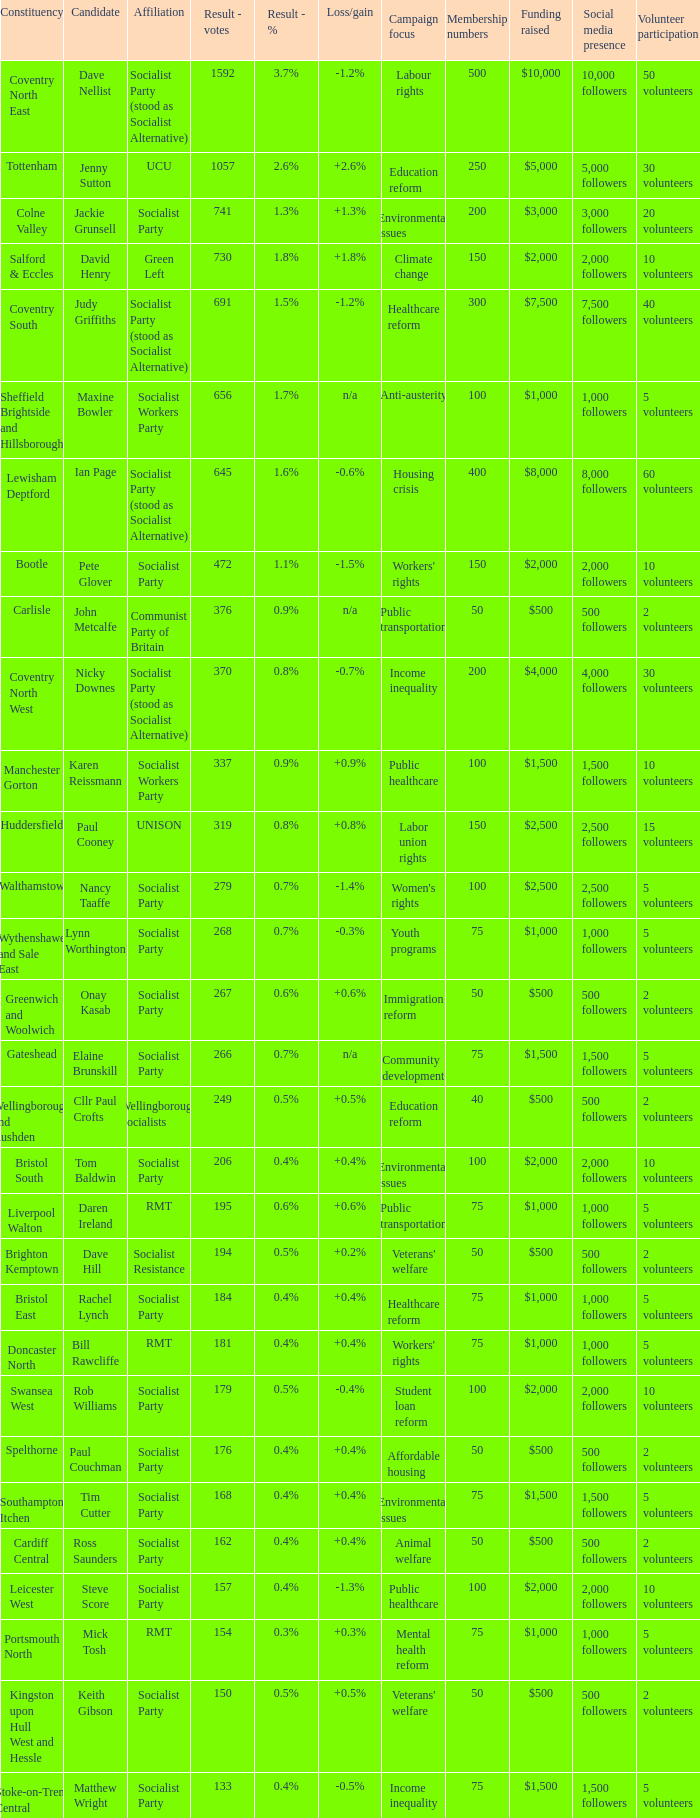Would you be able to parse every entry in this table? {'header': ['Constituency', 'Candidate', 'Affiliation', 'Result - votes', 'Result - %', 'Loss/gain', 'Campaign focus', 'Membership numbers', 'Funding raised', 'Social media presence', 'Volunteer participation'], 'rows': [['Coventry North East', 'Dave Nellist', 'Socialist Party (stood as Socialist Alternative)', '1592', '3.7%', '-1.2%', 'Labour rights', '500', '$10,000', '10,000 followers', '50 volunteers'], ['Tottenham', 'Jenny Sutton', 'UCU', '1057', '2.6%', '+2.6%', 'Education reform', '250', '$5,000', '5,000 followers', '30 volunteers'], ['Colne Valley', 'Jackie Grunsell', 'Socialist Party', '741', '1.3%', '+1.3%', 'Environmental issues', '200', '$3,000', '3,000 followers', '20 volunteers'], ['Salford & Eccles', 'David Henry', 'Green Left', '730', '1.8%', '+1.8%', 'Climate change', '150', '$2,000', '2,000 followers', '10 volunteers'], ['Coventry South', 'Judy Griffiths', 'Socialist Party (stood as Socialist Alternative)', '691', '1.5%', '-1.2%', 'Healthcare reform', '300', '$7,500', '7,500 followers', '40 volunteers'], ['Sheffield Brightside and Hillsborough', 'Maxine Bowler', 'Socialist Workers Party', '656', '1.7%', 'n/a', 'Anti-austerity', '100', '$1,000', '1,000 followers', '5 volunteers'], ['Lewisham Deptford', 'Ian Page', 'Socialist Party (stood as Socialist Alternative)', '645', '1.6%', '-0.6%', 'Housing crisis', '400', '$8,000', '8,000 followers', '60 volunteers'], ['Bootle', 'Pete Glover', 'Socialist Party', '472', '1.1%', '-1.5%', "Workers' rights", '150', '$2,000', '2,000 followers', '10 volunteers'], ['Carlisle', 'John Metcalfe', 'Communist Party of Britain', '376', '0.9%', 'n/a', 'Public transportation', '50', '$500', '500 followers', '2 volunteers'], ['Coventry North West', 'Nicky Downes', 'Socialist Party (stood as Socialist Alternative)', '370', '0.8%', '-0.7%', 'Income inequality', '200', '$4,000', '4,000 followers', '30 volunteers'], ['Manchester Gorton', 'Karen Reissmann', 'Socialist Workers Party', '337', '0.9%', '+0.9%', 'Public healthcare', '100', '$1,500', '1,500 followers', '10 volunteers'], ['Huddersfield', 'Paul Cooney', 'UNISON', '319', '0.8%', '+0.8%', 'Labor union rights', '150', '$2,500', '2,500 followers', '15 volunteers'], ['Walthamstow', 'Nancy Taaffe', 'Socialist Party', '279', '0.7%', '-1.4%', "Women's rights", '100', '$2,500', '2,500 followers', '5 volunteers'], ['Wythenshawe and Sale East', 'Lynn Worthington', 'Socialist Party', '268', '0.7%', '-0.3%', 'Youth programs', '75', '$1,000', '1,000 followers', '5 volunteers'], ['Greenwich and Woolwich', 'Onay Kasab', 'Socialist Party', '267', '0.6%', '+0.6%', 'Immigration reform', '50', '$500', '500 followers', '2 volunteers'], ['Gateshead', 'Elaine Brunskill', 'Socialist Party', '266', '0.7%', 'n/a', 'Community development', '75', '$1,500', '1,500 followers', '5 volunteers'], ['Wellingborough and Rushden', 'Cllr Paul Crofts', 'Wellingborough Socialists', '249', '0.5%', '+0.5%', 'Education reform', '40', '$500', '500 followers', '2 volunteers'], ['Bristol South', 'Tom Baldwin', 'Socialist Party', '206', '0.4%', '+0.4%', 'Environmental issues', '100', '$2,000', '2,000 followers', '10 volunteers'], ['Liverpool Walton', 'Daren Ireland', 'RMT', '195', '0.6%', '+0.6%', 'Public transportation', '75', '$1,000', '1,000 followers', '5 volunteers'], ['Brighton Kemptown', 'Dave Hill', 'Socialist Resistance', '194', '0.5%', '+0.2%', "Veterans' welfare", '50', '$500', '500 followers', '2 volunteers'], ['Bristol East', 'Rachel Lynch', 'Socialist Party', '184', '0.4%', '+0.4%', 'Healthcare reform', '75', '$1,000', '1,000 followers', '5 volunteers'], ['Doncaster North', 'Bill Rawcliffe', 'RMT', '181', '0.4%', '+0.4%', "Workers' rights", '75', '$1,000', '1,000 followers', '5 volunteers'], ['Swansea West', 'Rob Williams', 'Socialist Party', '179', '0.5%', '-0.4%', 'Student loan reform', '100', '$2,000', '2,000 followers', '10 volunteers'], ['Spelthorne', 'Paul Couchman', 'Socialist Party', '176', '0.4%', '+0.4%', 'Affordable housing', '50', '$500', '500 followers', '2 volunteers'], ['Southampton Itchen', 'Tim Cutter', 'Socialist Party', '168', '0.4%', '+0.4%', 'Environmental issues', '75', '$1,500', '1,500 followers', '5 volunteers'], ['Cardiff Central', 'Ross Saunders', 'Socialist Party', '162', '0.4%', '+0.4%', 'Animal welfare', '50', '$500', '500 followers', '2 volunteers'], ['Leicester West', 'Steve Score', 'Socialist Party', '157', '0.4%', '-1.3%', 'Public healthcare', '100', '$2,000', '2,000 followers', '10 volunteers'], ['Portsmouth North', 'Mick Tosh', 'RMT', '154', '0.3%', '+0.3%', 'Mental health reform', '75', '$1,000', '1,000 followers', '5 volunteers'], ['Kingston upon Hull West and Hessle', 'Keith Gibson', 'Socialist Party', '150', '0.5%', '+0.5%', "Veterans' welfare", '50', '$500', '500 followers', '2 volunteers'], ['Stoke-on-Trent Central', 'Matthew Wright', 'Socialist Party', '133', '0.4%', '-0.5%', 'Income inequality', '75', '$1,500', '1,500 followers', '5 volunteers']]} What is every affiliation for candidate Daren Ireland? RMT. 